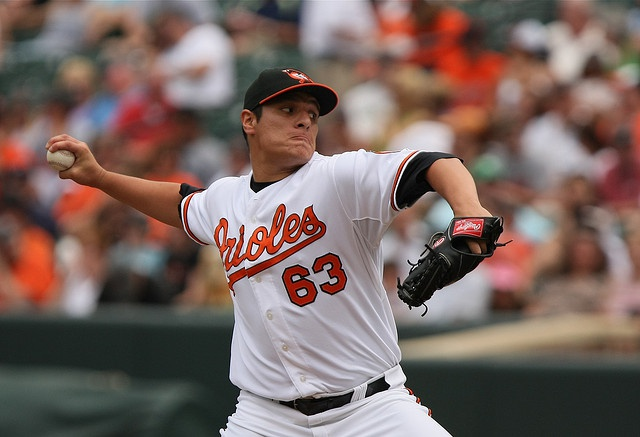Describe the objects in this image and their specific colors. I can see people in gray, darkgray, lavender, and black tones, people in gray, brown, and maroon tones, people in gray, darkgray, and lightgray tones, people in gray, darkgray, maroon, and brown tones, and baseball glove in gray, black, darkgray, and maroon tones in this image. 